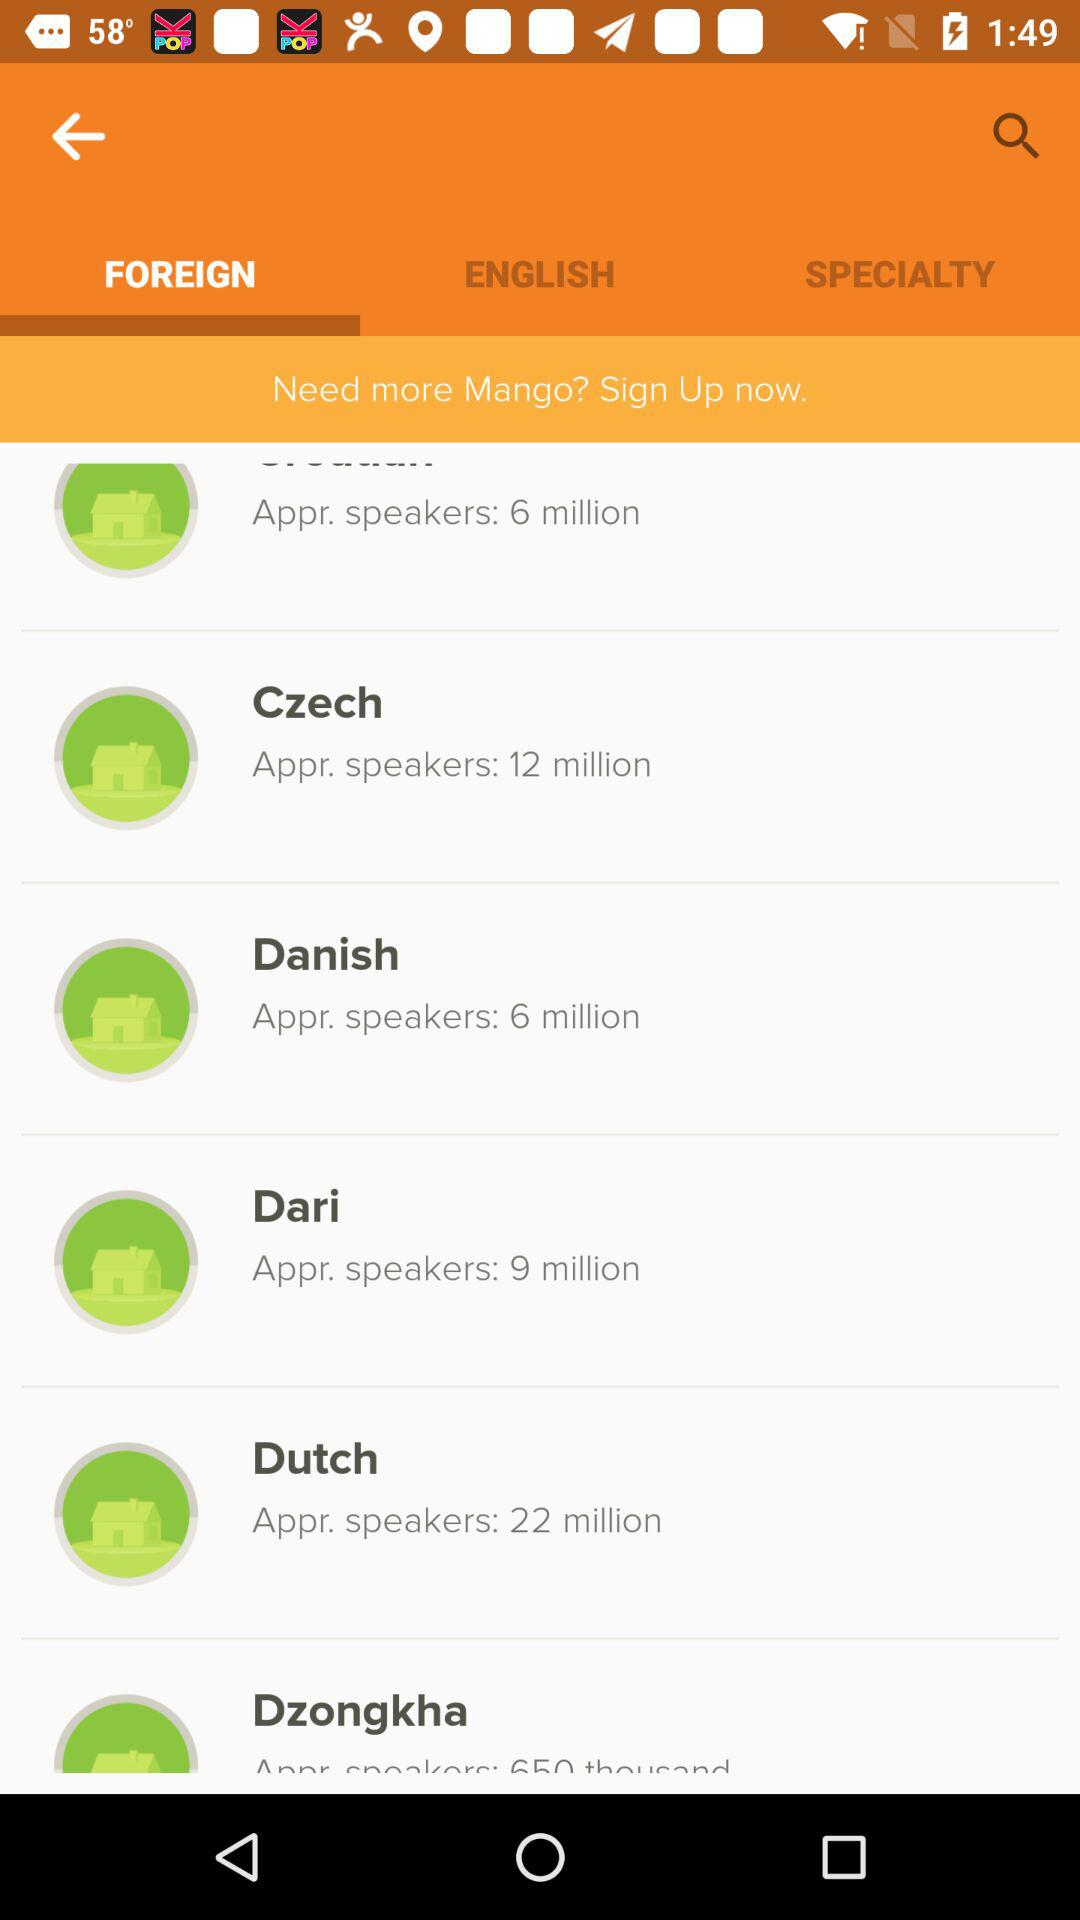Which tab is selected? The selected tab is "FOREIGN". 